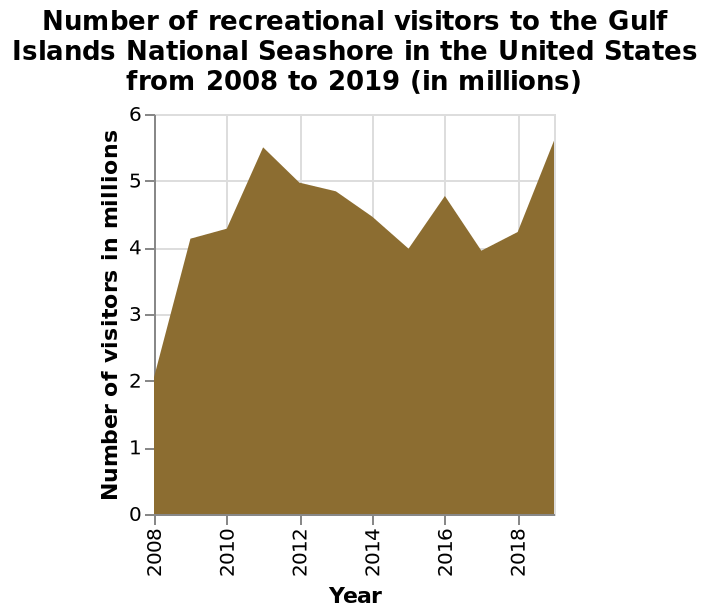<image>
What is the maximum number of visitors shown on the graph?  The maximum number of visitors shown on the graph is 6 million. What is the range of visitors from 2009?  The range of visitors from 2009 is 4 to 5 million. What does the x-axis measure?  The x-axis measures the year with a linear scale ranging from 2008 to 2018. Offer a thorough analysis of the image. Visitirs are remaining steady at 4 to 5 million from 2009. 